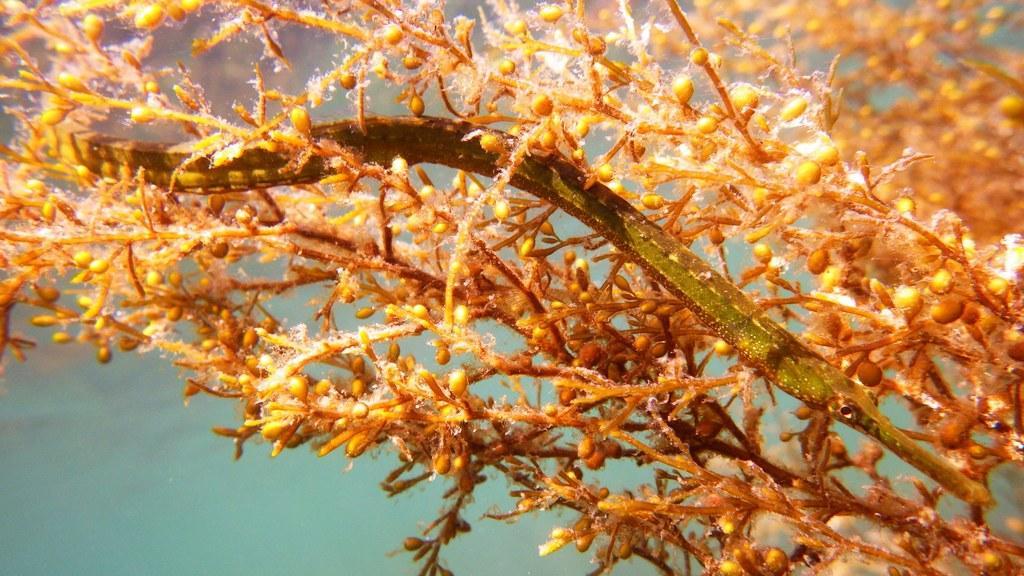Could you give a brief overview of what you see in this image? We can see stems. In the background it is green color. 